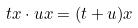Convert formula to latex. <formula><loc_0><loc_0><loc_500><loc_500>t x \cdot u x = ( t + u ) x</formula> 